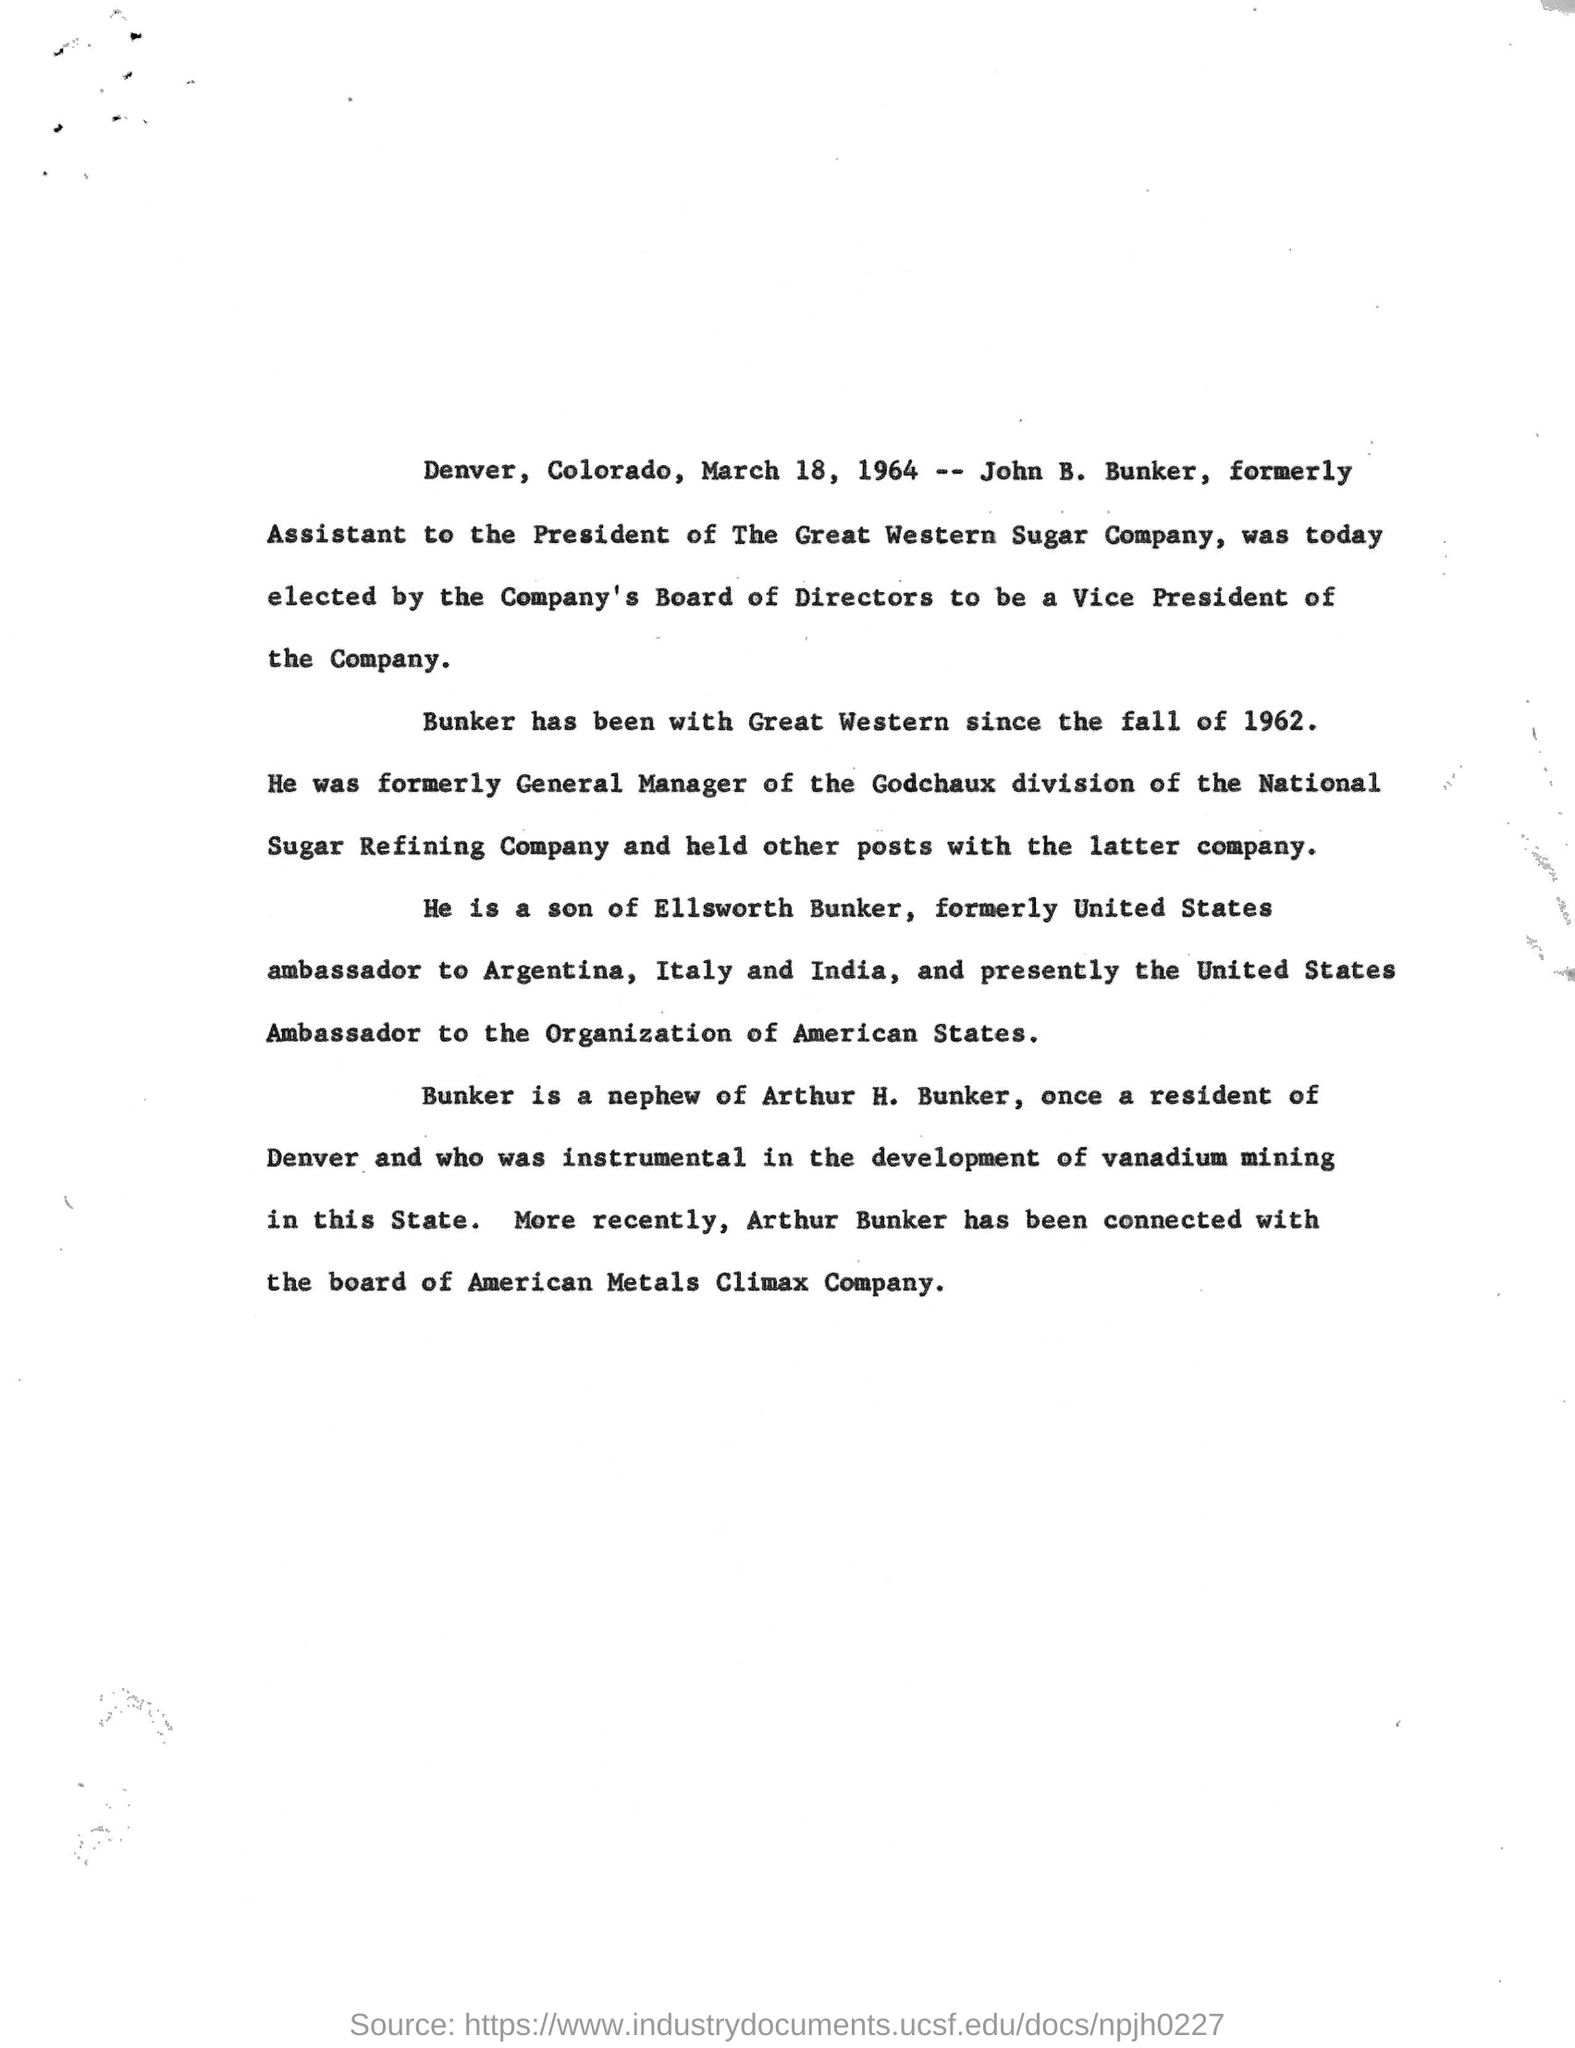Who is elected as the Vice President of The great Western Sugar Company?
Give a very brief answer. John B. Bunker. What was John B. Bunker designated earlier to being elected as Vice President?
Offer a very short reply. ASSISTANT TO THE PRESIDENT. How long since John B.Bunker is associated with the Great western Sugar Company?
Offer a very short reply. Since the fall of 1962. Who is the nephew of arthur h. bunker?
Give a very brief answer. Bunker. 